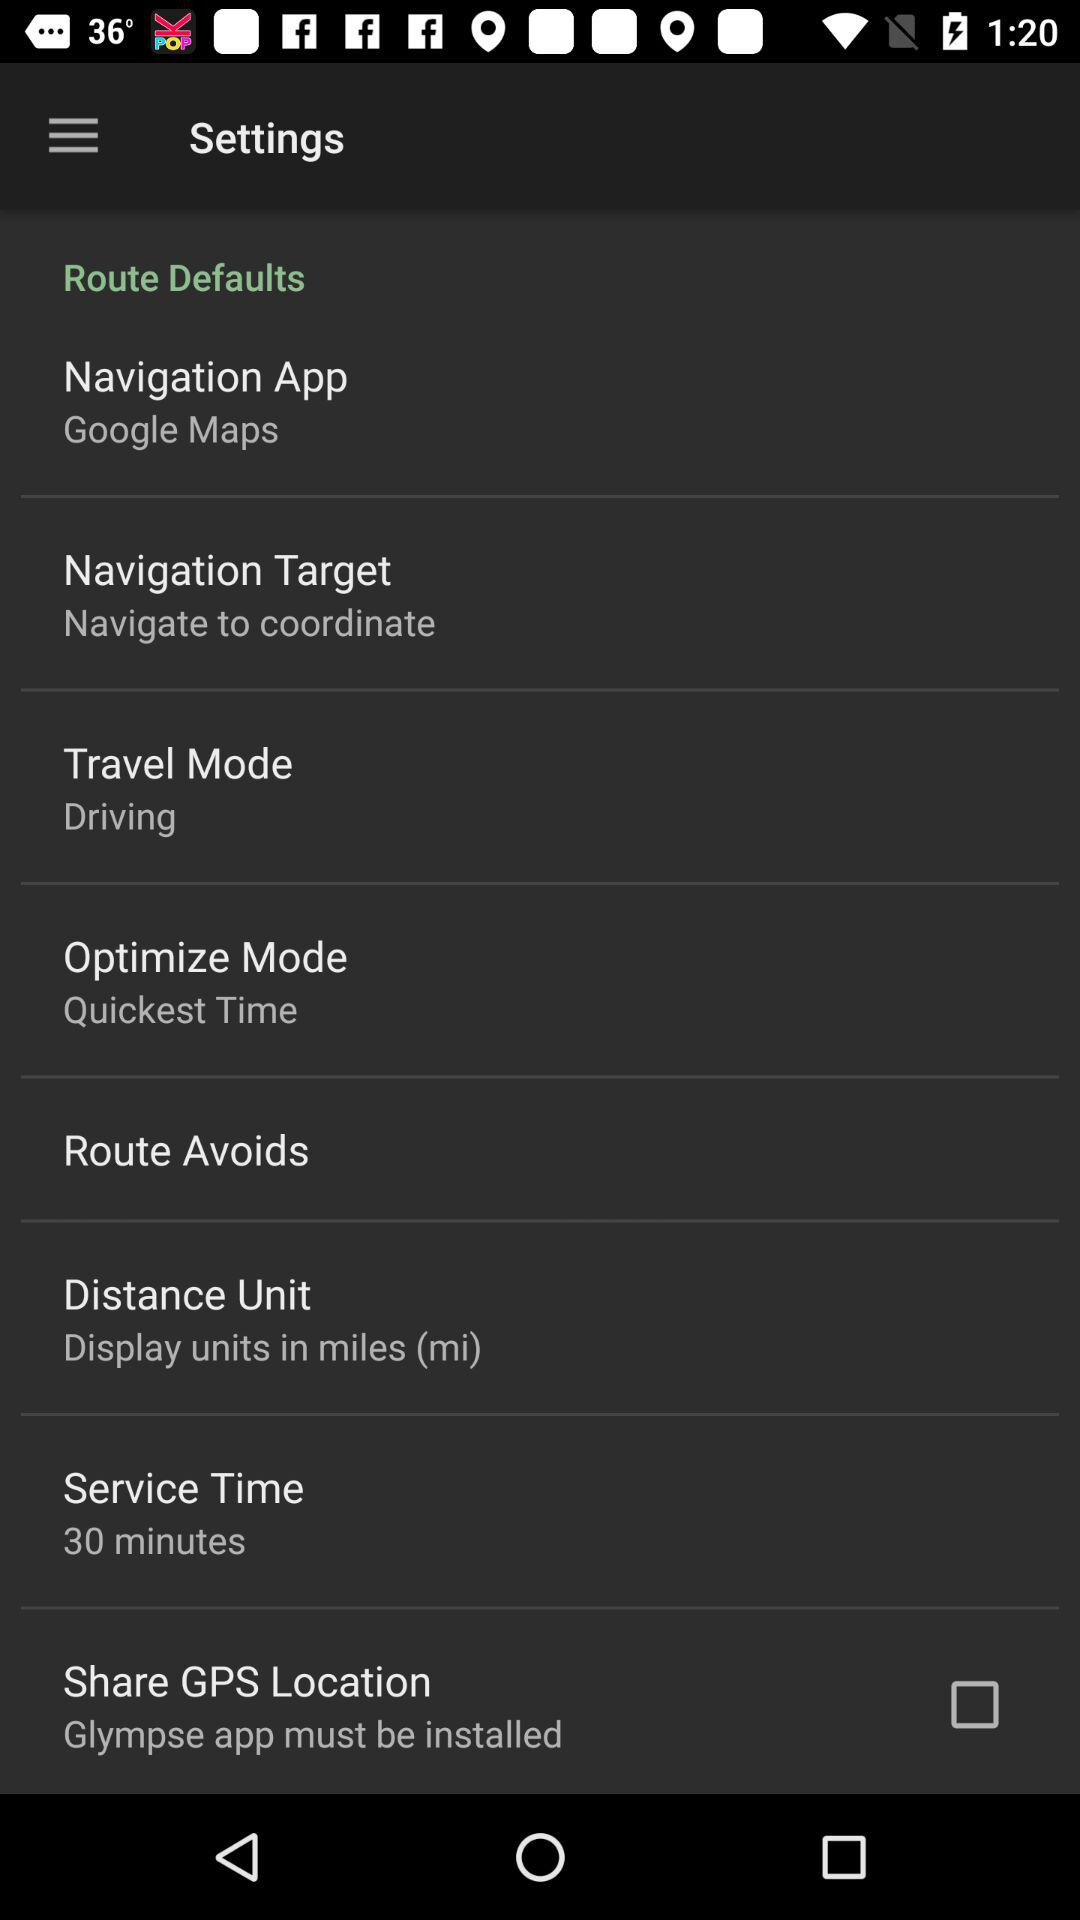What is the status of "Share GPS location"? The status is "off". 